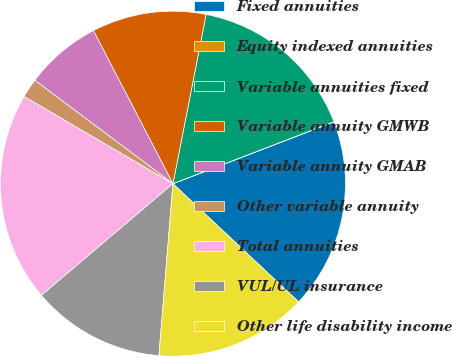<chart> <loc_0><loc_0><loc_500><loc_500><pie_chart><fcel>Fixed annuities<fcel>Equity indexed annuities<fcel>Variable annuities fixed<fcel>Variable annuity GMWB<fcel>Variable annuity GMAB<fcel>Other variable annuity<fcel>Total annuities<fcel>VUL/UL insurance<fcel>Other life disability income<nl><fcel>17.85%<fcel>0.01%<fcel>16.07%<fcel>10.71%<fcel>7.15%<fcel>1.79%<fcel>19.64%<fcel>12.5%<fcel>14.28%<nl></chart> 